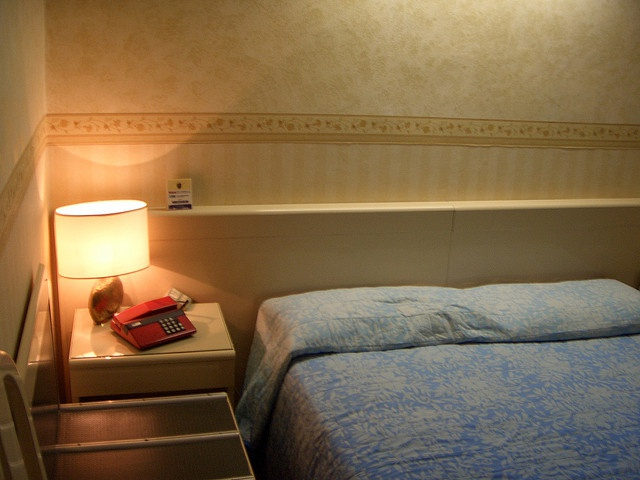Describe the objects in this image and their specific colors. I can see bed in olive, gray, darkgray, and black tones and chair in olive, black, maroon, and brown tones in this image. 